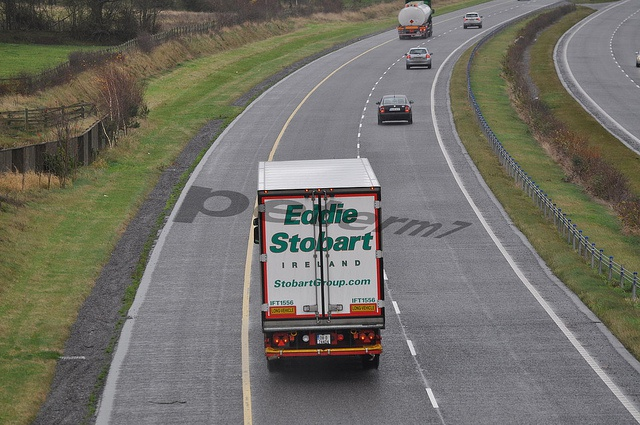Describe the objects in this image and their specific colors. I can see truck in black, darkgray, lightgray, and gray tones, truck in black, darkgray, gray, and brown tones, car in black, darkgray, and gray tones, car in black, gray, and darkgray tones, and car in black, darkgray, gray, and lightgray tones in this image. 